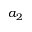<formula> <loc_0><loc_0><loc_500><loc_500>a _ { 2 }</formula> 